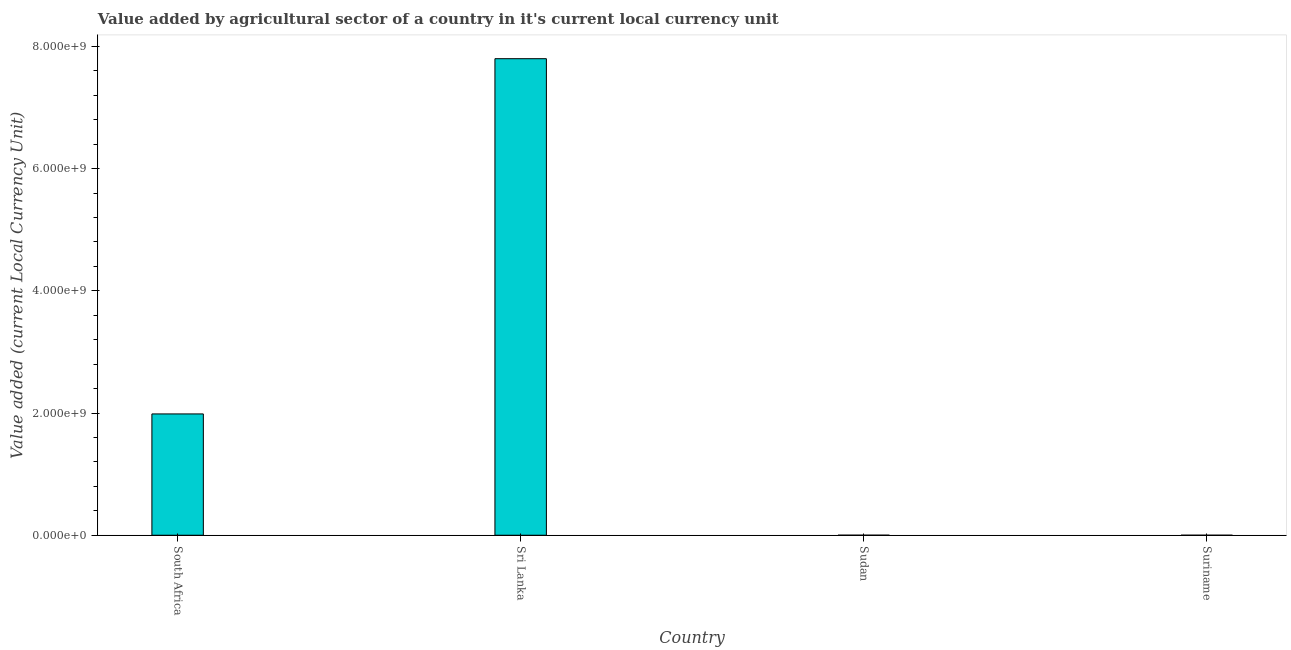What is the title of the graph?
Make the answer very short. Value added by agricultural sector of a country in it's current local currency unit. What is the label or title of the X-axis?
Provide a succinct answer. Country. What is the label or title of the Y-axis?
Offer a terse response. Value added (current Local Currency Unit). What is the value added by agriculture sector in Suriname?
Offer a very short reply. 5.81e+04. Across all countries, what is the maximum value added by agriculture sector?
Your answer should be very brief. 7.80e+09. Across all countries, what is the minimum value added by agriculture sector?
Offer a very short reply. 5.81e+04. In which country was the value added by agriculture sector maximum?
Offer a terse response. Sri Lanka. In which country was the value added by agriculture sector minimum?
Your answer should be very brief. Suriname. What is the sum of the value added by agriculture sector?
Your answer should be very brief. 9.78e+09. What is the difference between the value added by agriculture sector in South Africa and Sri Lanka?
Give a very brief answer. -5.81e+09. What is the average value added by agriculture sector per country?
Your answer should be very brief. 2.45e+09. What is the median value added by agriculture sector?
Your answer should be very brief. 9.93e+08. What is the ratio of the value added by agriculture sector in South Africa to that in Suriname?
Your response must be concise. 3.42e+04. Is the difference between the value added by agriculture sector in South Africa and Sri Lanka greater than the difference between any two countries?
Ensure brevity in your answer.  No. What is the difference between the highest and the second highest value added by agriculture sector?
Ensure brevity in your answer.  5.81e+09. Is the sum of the value added by agriculture sector in South Africa and Suriname greater than the maximum value added by agriculture sector across all countries?
Your answer should be very brief. No. What is the difference between the highest and the lowest value added by agriculture sector?
Your answer should be compact. 7.80e+09. In how many countries, is the value added by agriculture sector greater than the average value added by agriculture sector taken over all countries?
Give a very brief answer. 1. What is the difference between two consecutive major ticks on the Y-axis?
Ensure brevity in your answer.  2.00e+09. What is the Value added (current Local Currency Unit) of South Africa?
Keep it short and to the point. 1.98e+09. What is the Value added (current Local Currency Unit) in Sri Lanka?
Keep it short and to the point. 7.80e+09. What is the Value added (current Local Currency Unit) in Sudan?
Offer a very short reply. 6.01e+05. What is the Value added (current Local Currency Unit) in Suriname?
Your response must be concise. 5.81e+04. What is the difference between the Value added (current Local Currency Unit) in South Africa and Sri Lanka?
Provide a short and direct response. -5.81e+09. What is the difference between the Value added (current Local Currency Unit) in South Africa and Sudan?
Your response must be concise. 1.98e+09. What is the difference between the Value added (current Local Currency Unit) in South Africa and Suriname?
Make the answer very short. 1.98e+09. What is the difference between the Value added (current Local Currency Unit) in Sri Lanka and Sudan?
Provide a short and direct response. 7.80e+09. What is the difference between the Value added (current Local Currency Unit) in Sri Lanka and Suriname?
Your response must be concise. 7.80e+09. What is the difference between the Value added (current Local Currency Unit) in Sudan and Suriname?
Offer a very short reply. 5.43e+05. What is the ratio of the Value added (current Local Currency Unit) in South Africa to that in Sri Lanka?
Provide a succinct answer. 0.26. What is the ratio of the Value added (current Local Currency Unit) in South Africa to that in Sudan?
Provide a short and direct response. 3300.63. What is the ratio of the Value added (current Local Currency Unit) in South Africa to that in Suriname?
Make the answer very short. 3.42e+04. What is the ratio of the Value added (current Local Currency Unit) in Sri Lanka to that in Sudan?
Keep it short and to the point. 1.30e+04. What is the ratio of the Value added (current Local Currency Unit) in Sri Lanka to that in Suriname?
Provide a succinct answer. 1.34e+05. What is the ratio of the Value added (current Local Currency Unit) in Sudan to that in Suriname?
Your response must be concise. 10.35. 